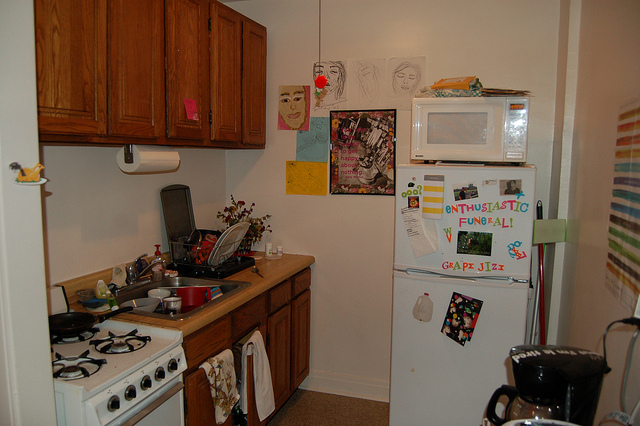<image>What type of drink ware is on top of the cabinet? There is no drink ware on top of the cabinet. But it can be seen a cup or a drinking glass. What type of drink ware is on top of the cabinet? I am not sure what type of drink ware is on top of the cabinet. It can be a cup, water, coffee cups, or a drinking glass. 